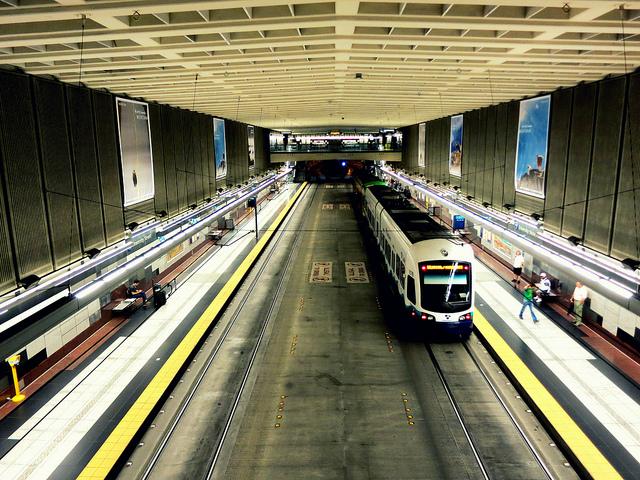How many trains are there?
Give a very brief answer. 1. Can you see any people?
Be succinct. Yes. Does this train carry passengers?
Give a very brief answer. Yes. 